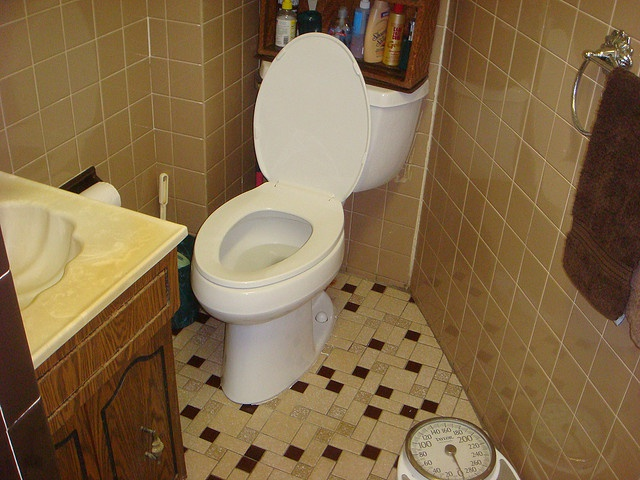Describe the objects in this image and their specific colors. I can see toilet in maroon, darkgray, tan, and gray tones, sink in maroon and tan tones, bottle in maroon, gray, and olive tones, bottle in maroon, darkgray, gray, and black tones, and bottle in maroon, olive, and gray tones in this image. 